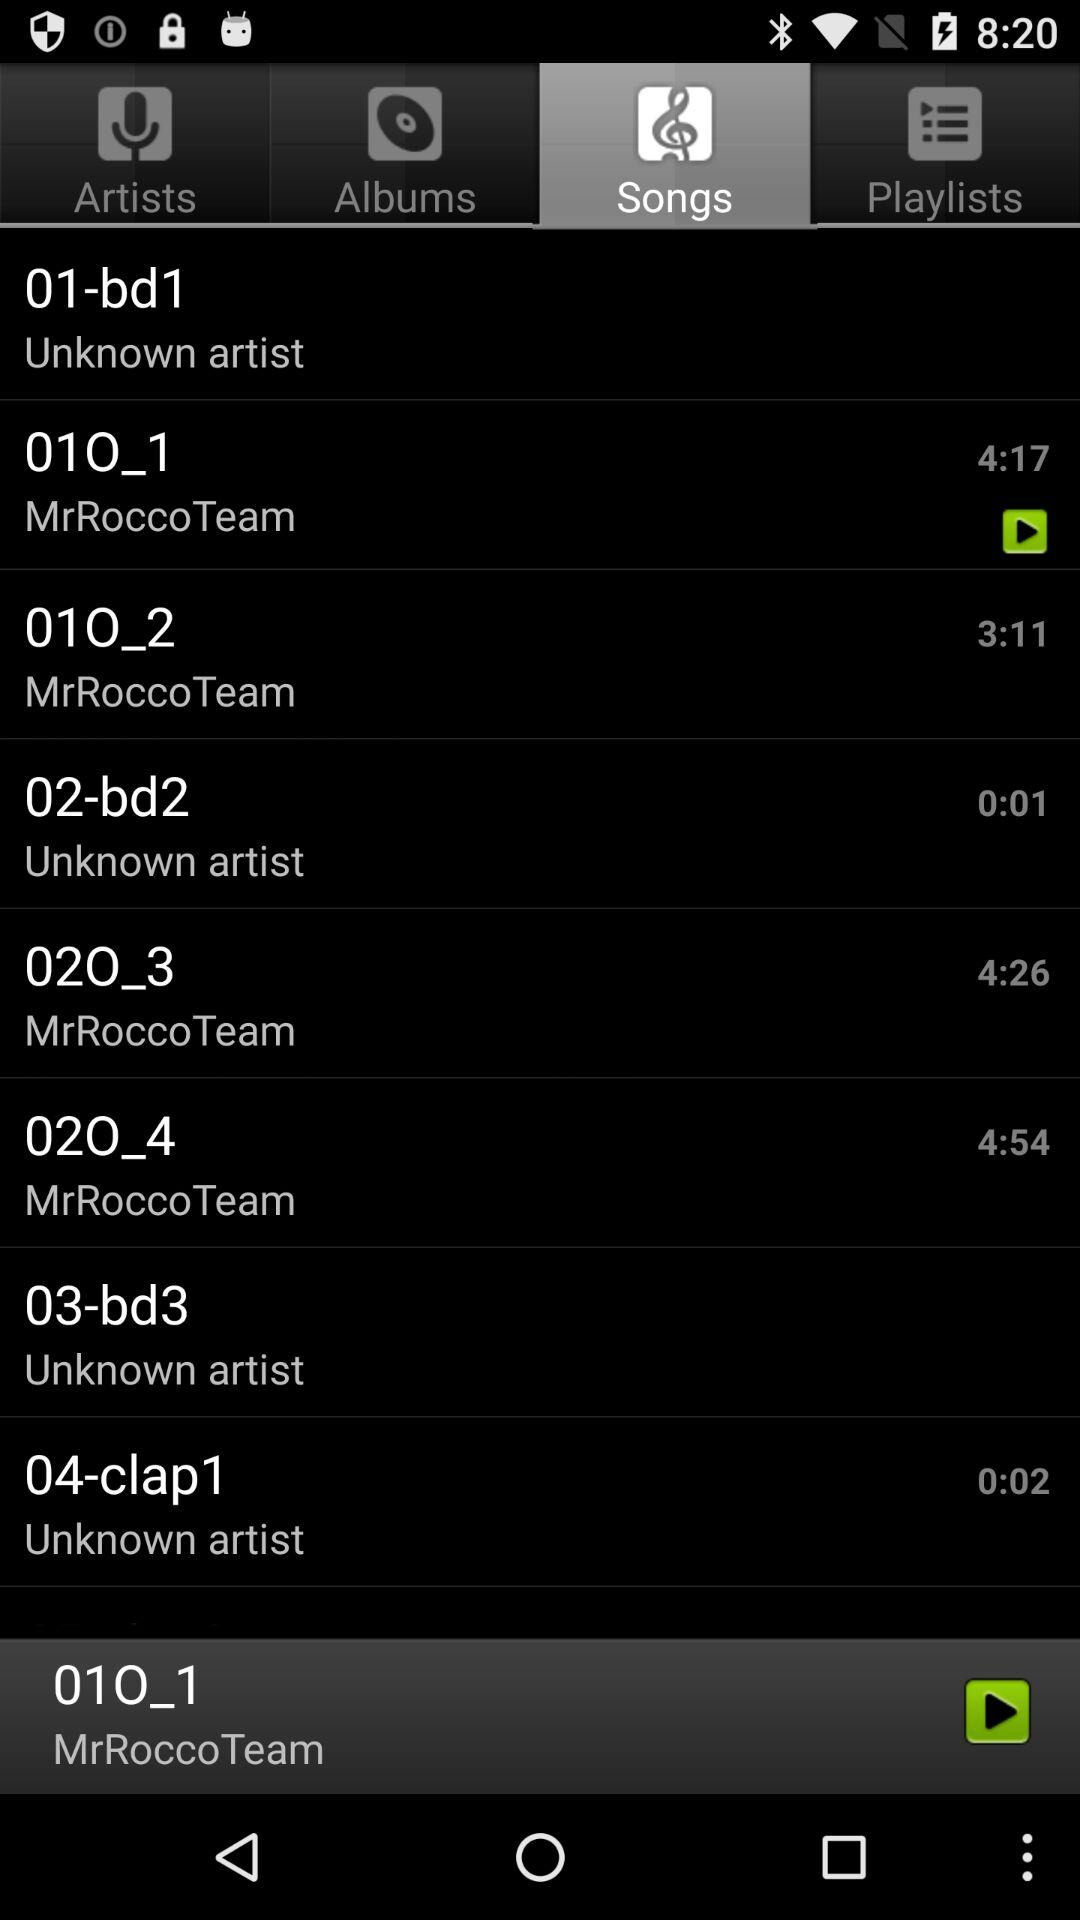What is the time duration of song "010_2"? The time duration of song "010_2" is 3 minutes and 11 seconds. 